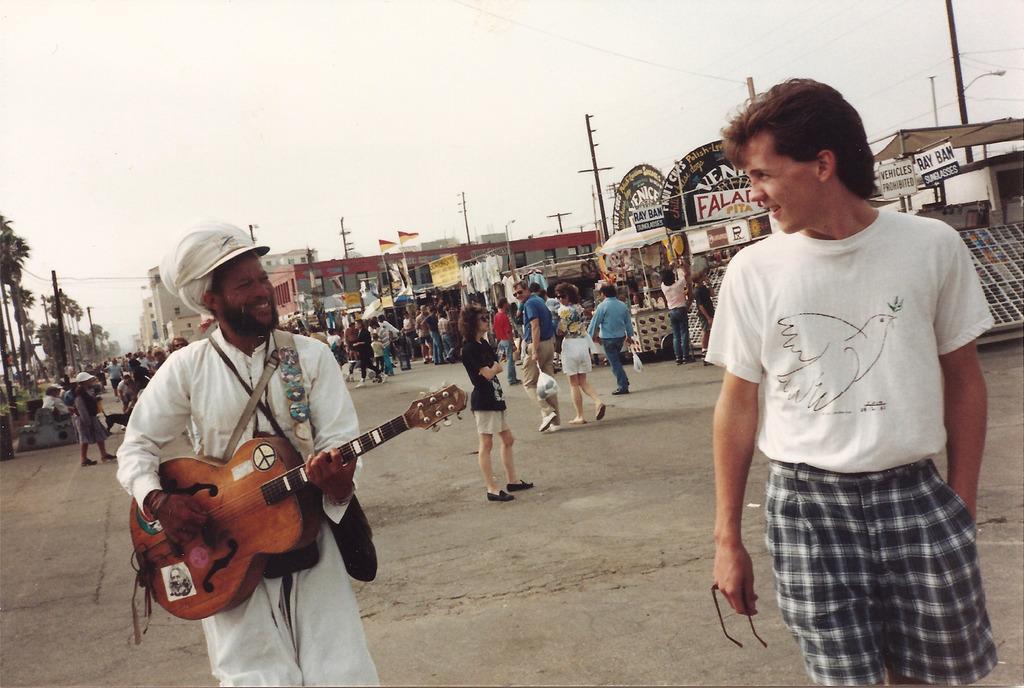How would you summarize this image in a sentence or two? It is an exhibition , there are lot of people here the first two people are looking at each other , the first person is holding spectacles in his hand the second person is holding a guitar and he is wearing a hat, behind them there are some stalls lot of stalls , poles and in the background there are lot of trees , sky. 